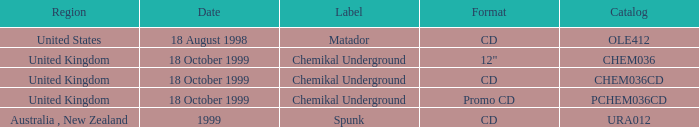What label has a catalog of chem036cd? Chemikal Underground. 